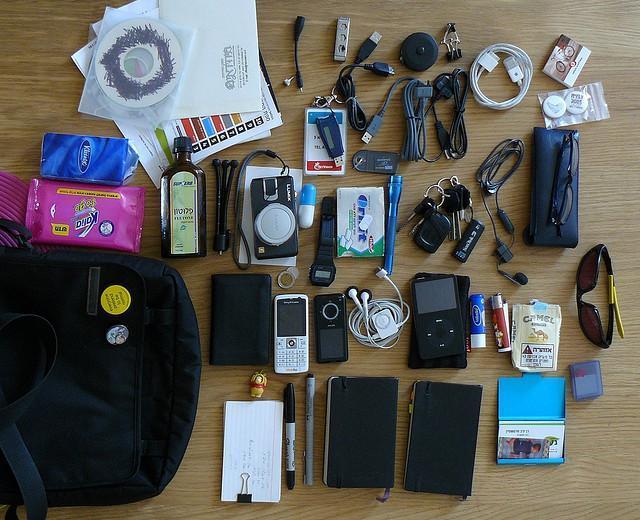How many batteries are in the charger?
Give a very brief answer. 0. 